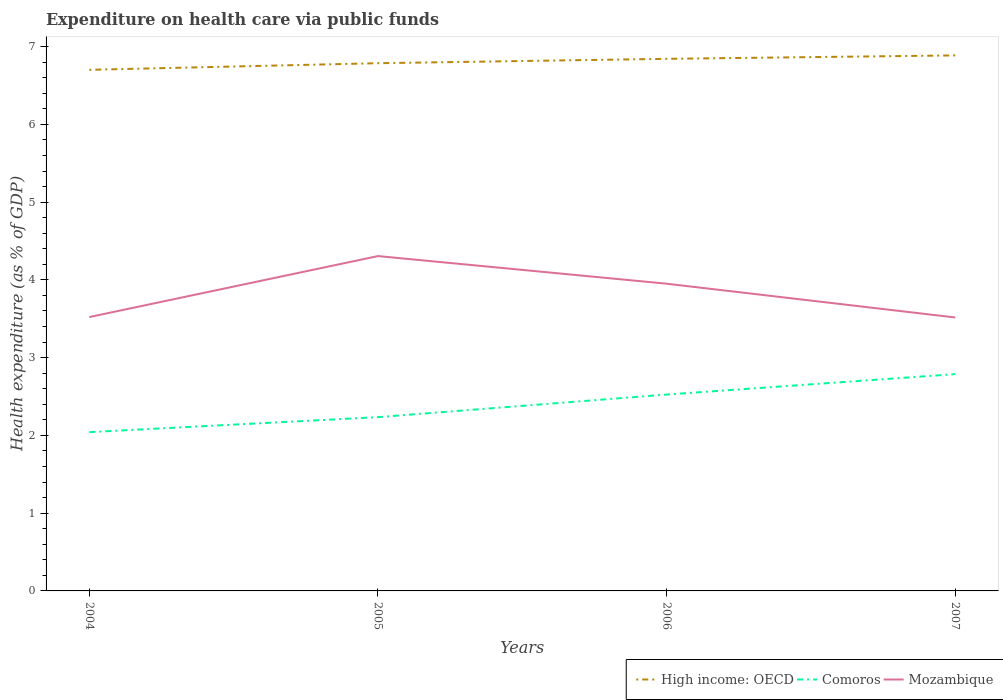How many different coloured lines are there?
Give a very brief answer. 3. Across all years, what is the maximum expenditure made on health care in High income: OECD?
Your answer should be very brief. 6.7. What is the total expenditure made on health care in Mozambique in the graph?
Give a very brief answer. 0.36. What is the difference between the highest and the second highest expenditure made on health care in High income: OECD?
Ensure brevity in your answer.  0.19. Is the expenditure made on health care in Mozambique strictly greater than the expenditure made on health care in High income: OECD over the years?
Your response must be concise. Yes. What is the difference between two consecutive major ticks on the Y-axis?
Your response must be concise. 1. How are the legend labels stacked?
Your response must be concise. Horizontal. What is the title of the graph?
Make the answer very short. Expenditure on health care via public funds. What is the label or title of the X-axis?
Your answer should be compact. Years. What is the label or title of the Y-axis?
Offer a terse response. Health expenditure (as % of GDP). What is the Health expenditure (as % of GDP) of High income: OECD in 2004?
Offer a very short reply. 6.7. What is the Health expenditure (as % of GDP) of Comoros in 2004?
Make the answer very short. 2.04. What is the Health expenditure (as % of GDP) of Mozambique in 2004?
Your answer should be compact. 3.52. What is the Health expenditure (as % of GDP) of High income: OECD in 2005?
Ensure brevity in your answer.  6.79. What is the Health expenditure (as % of GDP) in Comoros in 2005?
Offer a terse response. 2.23. What is the Health expenditure (as % of GDP) of Mozambique in 2005?
Keep it short and to the point. 4.31. What is the Health expenditure (as % of GDP) of High income: OECD in 2006?
Ensure brevity in your answer.  6.84. What is the Health expenditure (as % of GDP) of Comoros in 2006?
Make the answer very short. 2.53. What is the Health expenditure (as % of GDP) in Mozambique in 2006?
Your answer should be compact. 3.95. What is the Health expenditure (as % of GDP) in High income: OECD in 2007?
Ensure brevity in your answer.  6.89. What is the Health expenditure (as % of GDP) in Comoros in 2007?
Offer a very short reply. 2.79. What is the Health expenditure (as % of GDP) of Mozambique in 2007?
Offer a terse response. 3.52. Across all years, what is the maximum Health expenditure (as % of GDP) of High income: OECD?
Provide a succinct answer. 6.89. Across all years, what is the maximum Health expenditure (as % of GDP) of Comoros?
Provide a succinct answer. 2.79. Across all years, what is the maximum Health expenditure (as % of GDP) in Mozambique?
Your response must be concise. 4.31. Across all years, what is the minimum Health expenditure (as % of GDP) in High income: OECD?
Offer a terse response. 6.7. Across all years, what is the minimum Health expenditure (as % of GDP) of Comoros?
Provide a succinct answer. 2.04. Across all years, what is the minimum Health expenditure (as % of GDP) of Mozambique?
Provide a succinct answer. 3.52. What is the total Health expenditure (as % of GDP) of High income: OECD in the graph?
Keep it short and to the point. 27.22. What is the total Health expenditure (as % of GDP) of Comoros in the graph?
Provide a short and direct response. 9.59. What is the total Health expenditure (as % of GDP) of Mozambique in the graph?
Provide a short and direct response. 15.3. What is the difference between the Health expenditure (as % of GDP) of High income: OECD in 2004 and that in 2005?
Provide a succinct answer. -0.09. What is the difference between the Health expenditure (as % of GDP) in Comoros in 2004 and that in 2005?
Your answer should be very brief. -0.19. What is the difference between the Health expenditure (as % of GDP) of Mozambique in 2004 and that in 2005?
Give a very brief answer. -0.78. What is the difference between the Health expenditure (as % of GDP) in High income: OECD in 2004 and that in 2006?
Your answer should be compact. -0.14. What is the difference between the Health expenditure (as % of GDP) in Comoros in 2004 and that in 2006?
Offer a terse response. -0.48. What is the difference between the Health expenditure (as % of GDP) in Mozambique in 2004 and that in 2006?
Make the answer very short. -0.43. What is the difference between the Health expenditure (as % of GDP) of High income: OECD in 2004 and that in 2007?
Your response must be concise. -0.19. What is the difference between the Health expenditure (as % of GDP) in Comoros in 2004 and that in 2007?
Your answer should be very brief. -0.75. What is the difference between the Health expenditure (as % of GDP) in Mozambique in 2004 and that in 2007?
Provide a short and direct response. 0.01. What is the difference between the Health expenditure (as % of GDP) of High income: OECD in 2005 and that in 2006?
Your answer should be compact. -0.06. What is the difference between the Health expenditure (as % of GDP) of Comoros in 2005 and that in 2006?
Provide a succinct answer. -0.29. What is the difference between the Health expenditure (as % of GDP) in Mozambique in 2005 and that in 2006?
Your answer should be very brief. 0.36. What is the difference between the Health expenditure (as % of GDP) of High income: OECD in 2005 and that in 2007?
Keep it short and to the point. -0.1. What is the difference between the Health expenditure (as % of GDP) in Comoros in 2005 and that in 2007?
Ensure brevity in your answer.  -0.55. What is the difference between the Health expenditure (as % of GDP) in Mozambique in 2005 and that in 2007?
Make the answer very short. 0.79. What is the difference between the Health expenditure (as % of GDP) of High income: OECD in 2006 and that in 2007?
Ensure brevity in your answer.  -0.04. What is the difference between the Health expenditure (as % of GDP) of Comoros in 2006 and that in 2007?
Make the answer very short. -0.26. What is the difference between the Health expenditure (as % of GDP) in Mozambique in 2006 and that in 2007?
Offer a terse response. 0.43. What is the difference between the Health expenditure (as % of GDP) in High income: OECD in 2004 and the Health expenditure (as % of GDP) in Comoros in 2005?
Ensure brevity in your answer.  4.47. What is the difference between the Health expenditure (as % of GDP) of High income: OECD in 2004 and the Health expenditure (as % of GDP) of Mozambique in 2005?
Your response must be concise. 2.4. What is the difference between the Health expenditure (as % of GDP) in Comoros in 2004 and the Health expenditure (as % of GDP) in Mozambique in 2005?
Ensure brevity in your answer.  -2.26. What is the difference between the Health expenditure (as % of GDP) of High income: OECD in 2004 and the Health expenditure (as % of GDP) of Comoros in 2006?
Your answer should be very brief. 4.18. What is the difference between the Health expenditure (as % of GDP) of High income: OECD in 2004 and the Health expenditure (as % of GDP) of Mozambique in 2006?
Keep it short and to the point. 2.75. What is the difference between the Health expenditure (as % of GDP) in Comoros in 2004 and the Health expenditure (as % of GDP) in Mozambique in 2006?
Your response must be concise. -1.91. What is the difference between the Health expenditure (as % of GDP) in High income: OECD in 2004 and the Health expenditure (as % of GDP) in Comoros in 2007?
Provide a succinct answer. 3.91. What is the difference between the Health expenditure (as % of GDP) of High income: OECD in 2004 and the Health expenditure (as % of GDP) of Mozambique in 2007?
Provide a short and direct response. 3.18. What is the difference between the Health expenditure (as % of GDP) in Comoros in 2004 and the Health expenditure (as % of GDP) in Mozambique in 2007?
Ensure brevity in your answer.  -1.47. What is the difference between the Health expenditure (as % of GDP) in High income: OECD in 2005 and the Health expenditure (as % of GDP) in Comoros in 2006?
Your answer should be very brief. 4.26. What is the difference between the Health expenditure (as % of GDP) of High income: OECD in 2005 and the Health expenditure (as % of GDP) of Mozambique in 2006?
Ensure brevity in your answer.  2.84. What is the difference between the Health expenditure (as % of GDP) of Comoros in 2005 and the Health expenditure (as % of GDP) of Mozambique in 2006?
Offer a terse response. -1.72. What is the difference between the Health expenditure (as % of GDP) in High income: OECD in 2005 and the Health expenditure (as % of GDP) in Comoros in 2007?
Your answer should be compact. 4. What is the difference between the Health expenditure (as % of GDP) of High income: OECD in 2005 and the Health expenditure (as % of GDP) of Mozambique in 2007?
Provide a short and direct response. 3.27. What is the difference between the Health expenditure (as % of GDP) in Comoros in 2005 and the Health expenditure (as % of GDP) in Mozambique in 2007?
Your answer should be very brief. -1.28. What is the difference between the Health expenditure (as % of GDP) in High income: OECD in 2006 and the Health expenditure (as % of GDP) in Comoros in 2007?
Your response must be concise. 4.05. What is the difference between the Health expenditure (as % of GDP) in High income: OECD in 2006 and the Health expenditure (as % of GDP) in Mozambique in 2007?
Your answer should be very brief. 3.33. What is the difference between the Health expenditure (as % of GDP) in Comoros in 2006 and the Health expenditure (as % of GDP) in Mozambique in 2007?
Your answer should be compact. -0.99. What is the average Health expenditure (as % of GDP) of High income: OECD per year?
Offer a terse response. 6.8. What is the average Health expenditure (as % of GDP) in Comoros per year?
Your response must be concise. 2.4. What is the average Health expenditure (as % of GDP) of Mozambique per year?
Make the answer very short. 3.82. In the year 2004, what is the difference between the Health expenditure (as % of GDP) in High income: OECD and Health expenditure (as % of GDP) in Comoros?
Give a very brief answer. 4.66. In the year 2004, what is the difference between the Health expenditure (as % of GDP) in High income: OECD and Health expenditure (as % of GDP) in Mozambique?
Your response must be concise. 3.18. In the year 2004, what is the difference between the Health expenditure (as % of GDP) of Comoros and Health expenditure (as % of GDP) of Mozambique?
Your answer should be compact. -1.48. In the year 2005, what is the difference between the Health expenditure (as % of GDP) in High income: OECD and Health expenditure (as % of GDP) in Comoros?
Keep it short and to the point. 4.55. In the year 2005, what is the difference between the Health expenditure (as % of GDP) of High income: OECD and Health expenditure (as % of GDP) of Mozambique?
Provide a succinct answer. 2.48. In the year 2005, what is the difference between the Health expenditure (as % of GDP) of Comoros and Health expenditure (as % of GDP) of Mozambique?
Your answer should be very brief. -2.07. In the year 2006, what is the difference between the Health expenditure (as % of GDP) in High income: OECD and Health expenditure (as % of GDP) in Comoros?
Ensure brevity in your answer.  4.32. In the year 2006, what is the difference between the Health expenditure (as % of GDP) in High income: OECD and Health expenditure (as % of GDP) in Mozambique?
Provide a succinct answer. 2.89. In the year 2006, what is the difference between the Health expenditure (as % of GDP) in Comoros and Health expenditure (as % of GDP) in Mozambique?
Keep it short and to the point. -1.43. In the year 2007, what is the difference between the Health expenditure (as % of GDP) in High income: OECD and Health expenditure (as % of GDP) in Comoros?
Keep it short and to the point. 4.1. In the year 2007, what is the difference between the Health expenditure (as % of GDP) in High income: OECD and Health expenditure (as % of GDP) in Mozambique?
Your answer should be compact. 3.37. In the year 2007, what is the difference between the Health expenditure (as % of GDP) of Comoros and Health expenditure (as % of GDP) of Mozambique?
Your answer should be compact. -0.73. What is the ratio of the Health expenditure (as % of GDP) in High income: OECD in 2004 to that in 2005?
Keep it short and to the point. 0.99. What is the ratio of the Health expenditure (as % of GDP) in Comoros in 2004 to that in 2005?
Your response must be concise. 0.91. What is the ratio of the Health expenditure (as % of GDP) of Mozambique in 2004 to that in 2005?
Give a very brief answer. 0.82. What is the ratio of the Health expenditure (as % of GDP) of High income: OECD in 2004 to that in 2006?
Provide a short and direct response. 0.98. What is the ratio of the Health expenditure (as % of GDP) in Comoros in 2004 to that in 2006?
Your response must be concise. 0.81. What is the ratio of the Health expenditure (as % of GDP) in Mozambique in 2004 to that in 2006?
Your answer should be very brief. 0.89. What is the ratio of the Health expenditure (as % of GDP) of High income: OECD in 2004 to that in 2007?
Offer a very short reply. 0.97. What is the ratio of the Health expenditure (as % of GDP) in Comoros in 2004 to that in 2007?
Offer a terse response. 0.73. What is the ratio of the Health expenditure (as % of GDP) in Mozambique in 2004 to that in 2007?
Your response must be concise. 1. What is the ratio of the Health expenditure (as % of GDP) of Comoros in 2005 to that in 2006?
Keep it short and to the point. 0.89. What is the ratio of the Health expenditure (as % of GDP) in Mozambique in 2005 to that in 2006?
Provide a succinct answer. 1.09. What is the ratio of the Health expenditure (as % of GDP) of High income: OECD in 2005 to that in 2007?
Make the answer very short. 0.99. What is the ratio of the Health expenditure (as % of GDP) in Comoros in 2005 to that in 2007?
Give a very brief answer. 0.8. What is the ratio of the Health expenditure (as % of GDP) of Mozambique in 2005 to that in 2007?
Offer a terse response. 1.22. What is the ratio of the Health expenditure (as % of GDP) in Comoros in 2006 to that in 2007?
Provide a succinct answer. 0.91. What is the ratio of the Health expenditure (as % of GDP) of Mozambique in 2006 to that in 2007?
Give a very brief answer. 1.12. What is the difference between the highest and the second highest Health expenditure (as % of GDP) in High income: OECD?
Ensure brevity in your answer.  0.04. What is the difference between the highest and the second highest Health expenditure (as % of GDP) in Comoros?
Keep it short and to the point. 0.26. What is the difference between the highest and the second highest Health expenditure (as % of GDP) of Mozambique?
Offer a very short reply. 0.36. What is the difference between the highest and the lowest Health expenditure (as % of GDP) in High income: OECD?
Provide a succinct answer. 0.19. What is the difference between the highest and the lowest Health expenditure (as % of GDP) in Comoros?
Offer a terse response. 0.75. What is the difference between the highest and the lowest Health expenditure (as % of GDP) of Mozambique?
Provide a short and direct response. 0.79. 